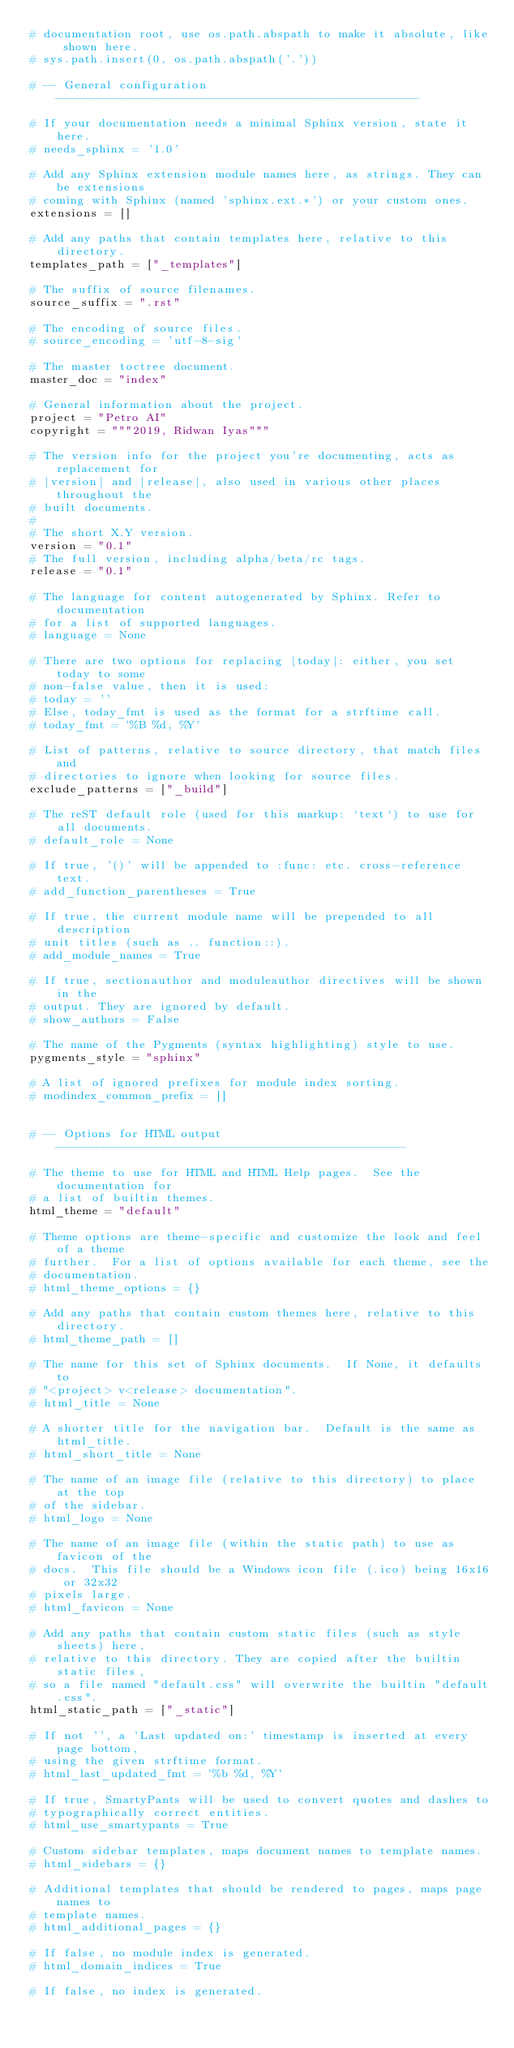Convert code to text. <code><loc_0><loc_0><loc_500><loc_500><_Python_># documentation root, use os.path.abspath to make it absolute, like shown here.
# sys.path.insert(0, os.path.abspath('.'))

# -- General configuration -----------------------------------------------------

# If your documentation needs a minimal Sphinx version, state it here.
# needs_sphinx = '1.0'

# Add any Sphinx extension module names here, as strings. They can be extensions
# coming with Sphinx (named 'sphinx.ext.*') or your custom ones.
extensions = []

# Add any paths that contain templates here, relative to this directory.
templates_path = ["_templates"]

# The suffix of source filenames.
source_suffix = ".rst"

# The encoding of source files.
# source_encoding = 'utf-8-sig'

# The master toctree document.
master_doc = "index"

# General information about the project.
project = "Petro AI"
copyright = """2019, Ridwan Iyas"""

# The version info for the project you're documenting, acts as replacement for
# |version| and |release|, also used in various other places throughout the
# built documents.
#
# The short X.Y version.
version = "0.1"
# The full version, including alpha/beta/rc tags.
release = "0.1"

# The language for content autogenerated by Sphinx. Refer to documentation
# for a list of supported languages.
# language = None

# There are two options for replacing |today|: either, you set today to some
# non-false value, then it is used:
# today = ''
# Else, today_fmt is used as the format for a strftime call.
# today_fmt = '%B %d, %Y'

# List of patterns, relative to source directory, that match files and
# directories to ignore when looking for source files.
exclude_patterns = ["_build"]

# The reST default role (used for this markup: `text`) to use for all documents.
# default_role = None

# If true, '()' will be appended to :func: etc. cross-reference text.
# add_function_parentheses = True

# If true, the current module name will be prepended to all description
# unit titles (such as .. function::).
# add_module_names = True

# If true, sectionauthor and moduleauthor directives will be shown in the
# output. They are ignored by default.
# show_authors = False

# The name of the Pygments (syntax highlighting) style to use.
pygments_style = "sphinx"

# A list of ignored prefixes for module index sorting.
# modindex_common_prefix = []


# -- Options for HTML output ---------------------------------------------------

# The theme to use for HTML and HTML Help pages.  See the documentation for
# a list of builtin themes.
html_theme = "default"

# Theme options are theme-specific and customize the look and feel of a theme
# further.  For a list of options available for each theme, see the
# documentation.
# html_theme_options = {}

# Add any paths that contain custom themes here, relative to this directory.
# html_theme_path = []

# The name for this set of Sphinx documents.  If None, it defaults to
# "<project> v<release> documentation".
# html_title = None

# A shorter title for the navigation bar.  Default is the same as html_title.
# html_short_title = None

# The name of an image file (relative to this directory) to place at the top
# of the sidebar.
# html_logo = None

# The name of an image file (within the static path) to use as favicon of the
# docs.  This file should be a Windows icon file (.ico) being 16x16 or 32x32
# pixels large.
# html_favicon = None

# Add any paths that contain custom static files (such as style sheets) here,
# relative to this directory. They are copied after the builtin static files,
# so a file named "default.css" will overwrite the builtin "default.css".
html_static_path = ["_static"]

# If not '', a 'Last updated on:' timestamp is inserted at every page bottom,
# using the given strftime format.
# html_last_updated_fmt = '%b %d, %Y'

# If true, SmartyPants will be used to convert quotes and dashes to
# typographically correct entities.
# html_use_smartypants = True

# Custom sidebar templates, maps document names to template names.
# html_sidebars = {}

# Additional templates that should be rendered to pages, maps page names to
# template names.
# html_additional_pages = {}

# If false, no module index is generated.
# html_domain_indices = True

# If false, no index is generated.</code> 